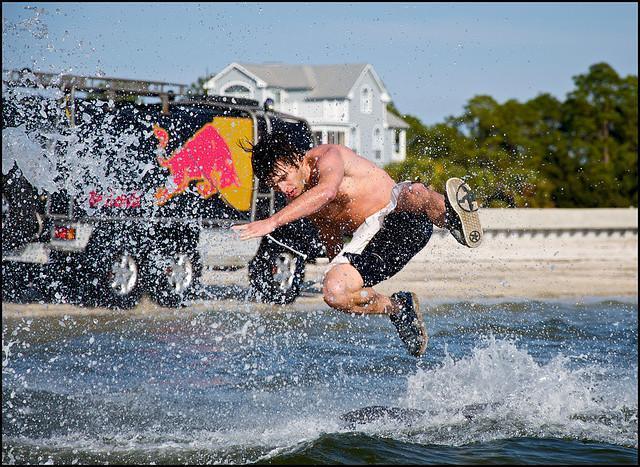How many remote controls are there?
Give a very brief answer. 0. 